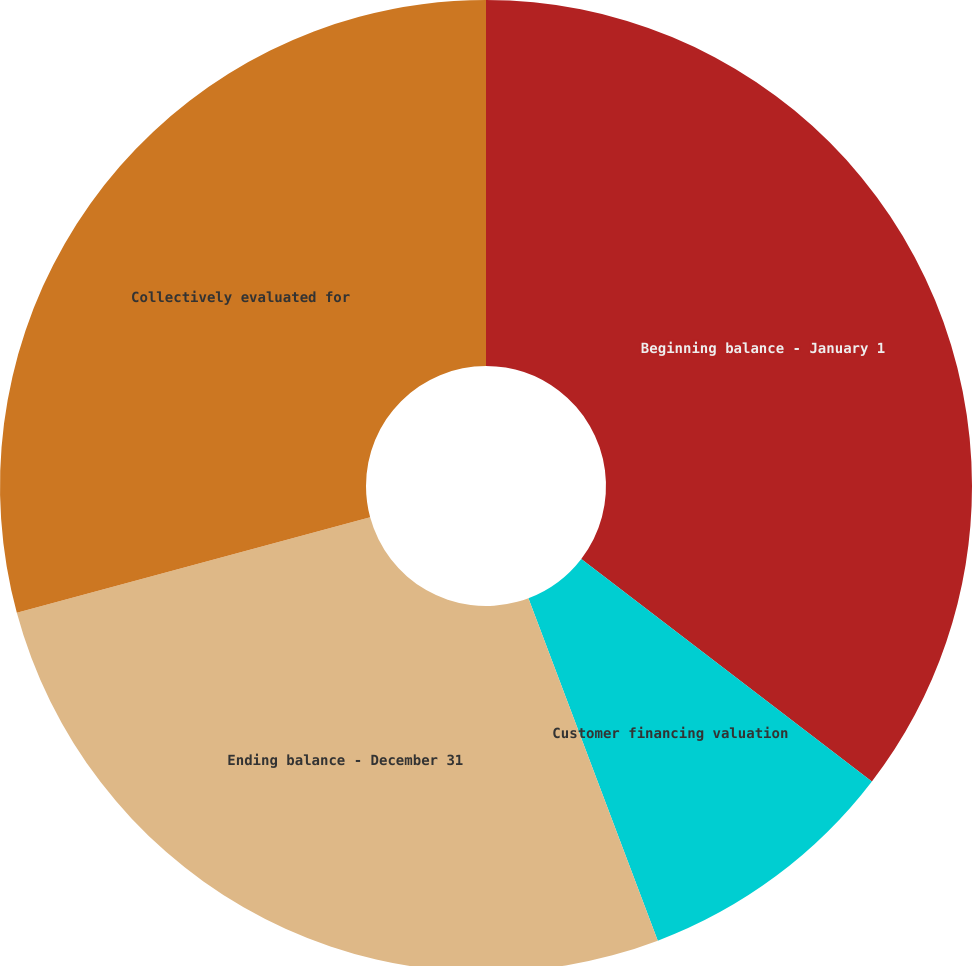Convert chart. <chart><loc_0><loc_0><loc_500><loc_500><pie_chart><fcel>Beginning balance - January 1<fcel>Customer financing valuation<fcel>Ending balance - December 31<fcel>Collectively evaluated for<nl><fcel>35.4%<fcel>8.85%<fcel>26.55%<fcel>29.2%<nl></chart> 